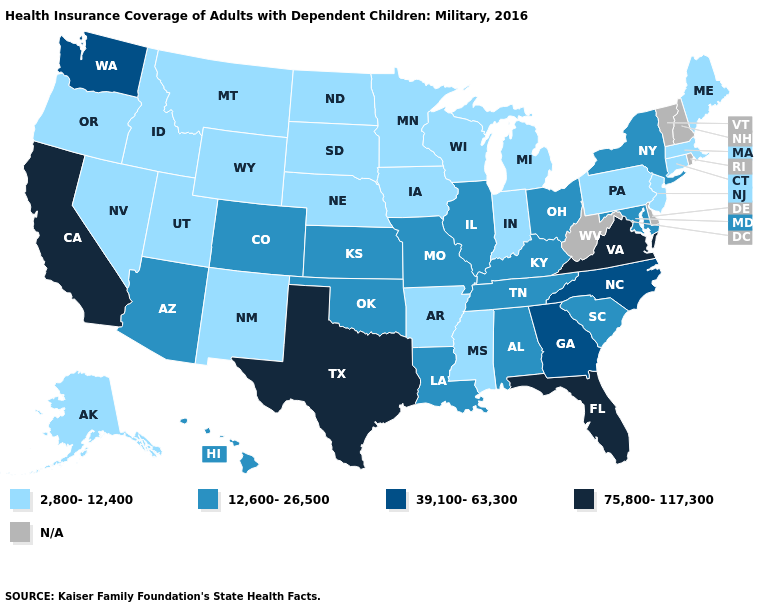Does Massachusetts have the lowest value in the USA?
Write a very short answer. Yes. What is the lowest value in the USA?
Write a very short answer. 2,800-12,400. Name the states that have a value in the range 39,100-63,300?
Short answer required. Georgia, North Carolina, Washington. Name the states that have a value in the range 75,800-117,300?
Keep it brief. California, Florida, Texas, Virginia. Among the states that border Michigan , does Ohio have the lowest value?
Be succinct. No. What is the highest value in the USA?
Short answer required. 75,800-117,300. What is the value of California?
Give a very brief answer. 75,800-117,300. Name the states that have a value in the range 75,800-117,300?
Be succinct. California, Florida, Texas, Virginia. What is the highest value in states that border Mississippi?
Quick response, please. 12,600-26,500. What is the lowest value in the South?
Give a very brief answer. 2,800-12,400. Does the map have missing data?
Short answer required. Yes. Does the map have missing data?
Keep it brief. Yes. 